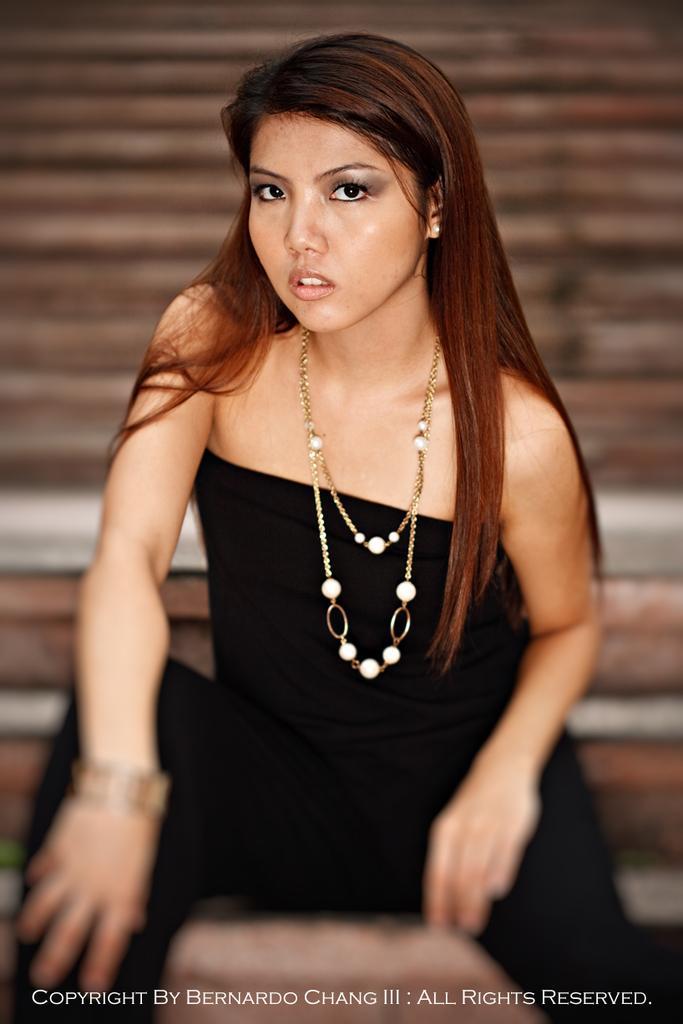Can you describe this image briefly? In this image I see a woman who is wearing black dress and I see that she is wearing necklace on her neck and I see that it is blurred over here. 